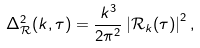<formula> <loc_0><loc_0><loc_500><loc_500>\Delta _ { \mathcal { R } } ^ { 2 } ( k , \tau ) = \frac { k ^ { 3 } } { 2 \pi ^ { 2 } } \left | \mathcal { R } _ { k } ( \tau ) \right | ^ { 2 } ,</formula> 